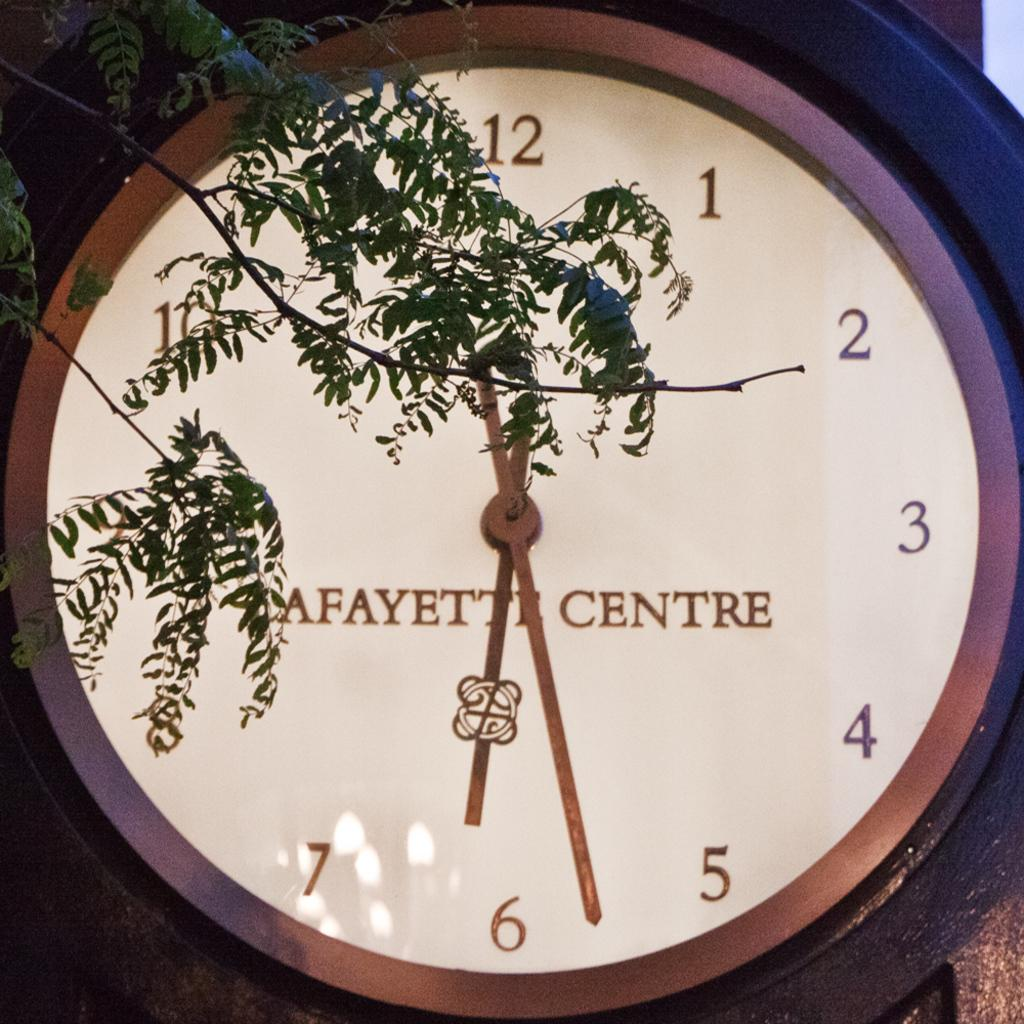<image>
Render a clear and concise summary of the photo. A clock shows the label saying "Lafayette Centre". 